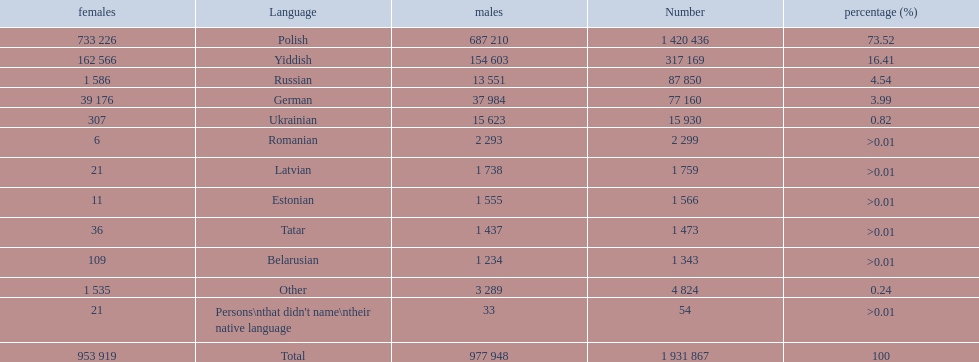Could you parse the entire table as a dict? {'header': ['females', 'Language', 'males', 'Number', 'percentage (%)'], 'rows': [['733 226', 'Polish', '687 210', '1 420 436', '73.52'], ['162 566', 'Yiddish', '154 603', '317 169', '16.41'], ['1 586', 'Russian', '13 551', '87 850', '4.54'], ['39 176', 'German', '37 984', '77 160', '3.99'], ['307', 'Ukrainian', '15 623', '15 930', '0.82'], ['6', 'Romanian', '2 293', '2 299', '>0.01'], ['21', 'Latvian', '1 738', '1 759', '>0.01'], ['11', 'Estonian', '1 555', '1 566', '>0.01'], ['36', 'Tatar', '1 437', '1 473', '>0.01'], ['109', 'Belarusian', '1 234', '1 343', '>0.01'], ['1 535', 'Other', '3 289', '4 824', '0.24'], ['21', "Persons\\nthat didn't name\\ntheir native language", '33', '54', '>0.01'], ['953 919', 'Total', '977 948', '1 931 867', '100']]} What was the top language from the one's whose percentage was >0.01 Romanian. 